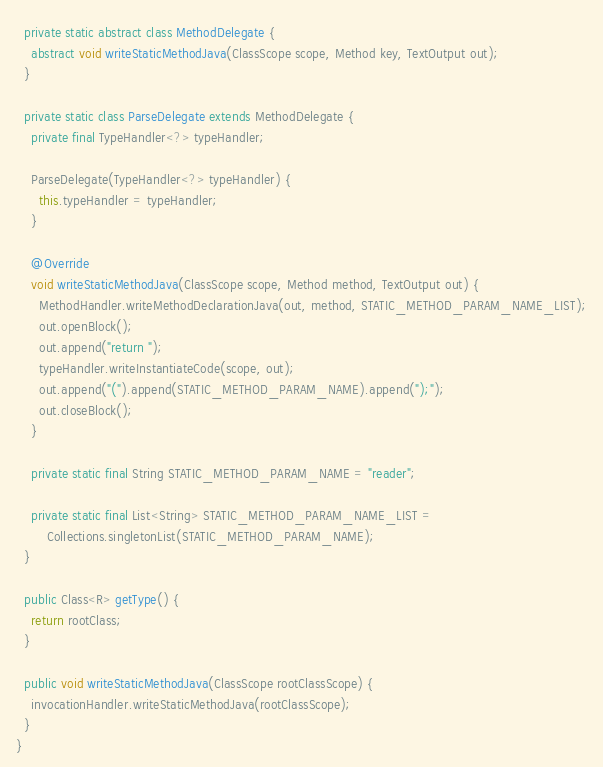<code> <loc_0><loc_0><loc_500><loc_500><_Java_>  private static abstract class MethodDelegate {
    abstract void writeStaticMethodJava(ClassScope scope, Method key, TextOutput out);
  }

  private static class ParseDelegate extends MethodDelegate {
    private final TypeHandler<?> typeHandler;

    ParseDelegate(TypeHandler<?> typeHandler) {
      this.typeHandler = typeHandler;
    }

    @Override
    void writeStaticMethodJava(ClassScope scope, Method method, TextOutput out) {
      MethodHandler.writeMethodDeclarationJava(out, method, STATIC_METHOD_PARAM_NAME_LIST);
      out.openBlock();
      out.append("return ");
      typeHandler.writeInstantiateCode(scope, out);
      out.append("(").append(STATIC_METHOD_PARAM_NAME).append(");");
      out.closeBlock();
    }

    private static final String STATIC_METHOD_PARAM_NAME = "reader";

    private static final List<String> STATIC_METHOD_PARAM_NAME_LIST =
        Collections.singletonList(STATIC_METHOD_PARAM_NAME);
  }

  public Class<R> getType() {
    return rootClass;
  }

  public void writeStaticMethodJava(ClassScope rootClassScope) {
    invocationHandler.writeStaticMethodJava(rootClassScope);
  }
}
</code> 